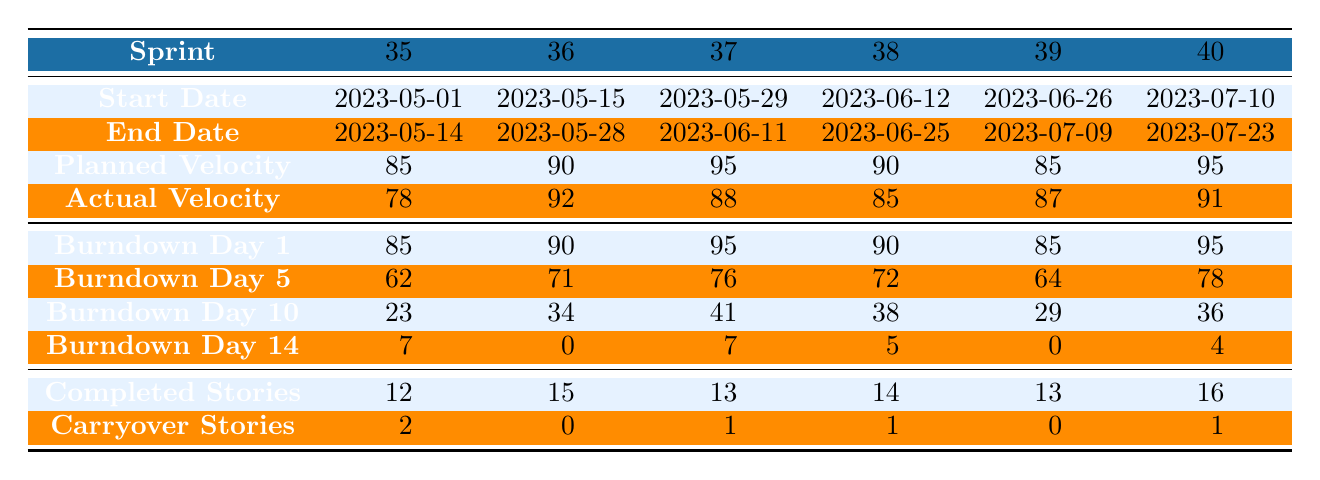What is the actual velocity for sprint 36? The table indicates the actual velocity for each sprint. For sprint number 36, the actual velocity is found in the "Actual Velocity" row under sprint 36, which shows a value of 92.
Answer: 92 How many carryover stories were there in sprint 39? The "Carryover Stories" row shows the number of carryover stories for each sprint. For sprint 39, the corresponding value under that row is 0.
Answer: 0 What is the difference between the planned velocity and actual velocity for sprint 38? To find the difference, first note the planned velocity for sprint 38, which is 90, and the actual velocity, which is 85. The difference is calculated as 90 - 85 = 5.
Answer: 5 On which sprint did the team have the highest actual velocity? By examining the "Actual Velocity" row, the values are 78, 92, 88, 85, 87, and 91. The highest value is 92 in sprint 36.
Answer: Sprint 36 What was the total number of completed stories across all sprints? Add the completed stories from each sprint: 12 + 15 + 13 + 14 + 13 + 16 = 83. So, the total completed stories is 83.
Answer: 83 Was the planned velocity for sprint 35 greater than the actual velocity? In the table, sprint 35's planned velocity is 85 and the actual velocity is 78. Since 85 is greater than 78, the statement is true.
Answer: Yes Which sprint had the lowest number of carryover stories, and what was that number? The "Carryover Stories" row shows the values: 2, 0, 1, 1, 0, 1. The lowest number is 0 in sprint 36 and sprint 39.
Answer: Sprint 36 and sprint 39, 0 What is the median planned velocity of the last 6 sprints? The planned velocities are 85, 90, 95, 90, 85, and 95. First, sort these: 85, 85, 90, 90, 95, 95. Since there are 6 values, the median is the average of the two middle numbers: (90 + 90) / 2 = 90.
Answer: 90 In sprint 40, how many stories were completed and how many carried over? From the table, for sprint 40, the completed stories are 16, and the carryover stories are 1. So, the completed is 16 and the carryover is 1.
Answer: Completed: 16, Carryover: 1 Which sprint had the most stories completed relative to its planned velocity? To analyze this, we compare the ratio of completed stories to planned velocity for each sprint. Sprint 36 has 15 completed out of 90 planned (ratio = 0.167), sprint 35 has 12 out of 85 (ratio = 0.141), sprint 37 has 13 out of 95 (ratio = 0.137), sprint 38 has 14 out of 90 (ratio = 0.156), sprint 39 has 13 out of 85 (ratio = 0.153), and sprint 40 has 16 out of 95 (ratio = 0.168). Sprint 40 has the highest ratio at approximately 0.168.
Answer: Sprint 40 